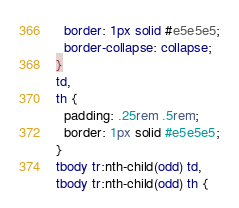Convert code to text. <code><loc_0><loc_0><loc_500><loc_500><_CSS_>  border: 1px solid #e5e5e5;
  border-collapse: collapse;
}
td,
th {
  padding: .25rem .5rem;
  border: 1px solid #e5e5e5;
}
tbody tr:nth-child(odd) td,
tbody tr:nth-child(odd) th {</code> 